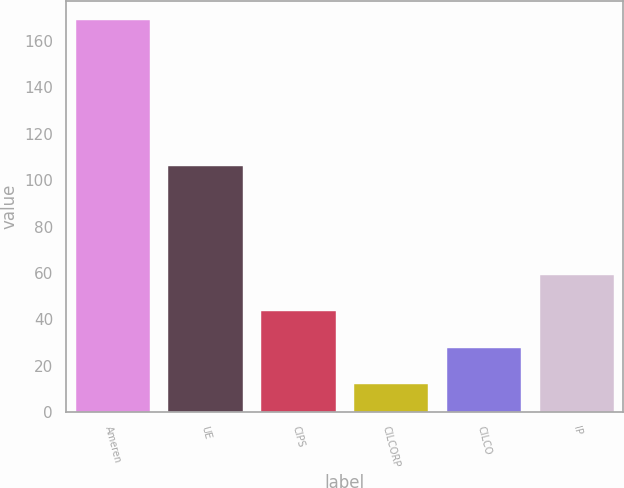Convert chart to OTSL. <chart><loc_0><loc_0><loc_500><loc_500><bar_chart><fcel>Ameren<fcel>UE<fcel>CIPS<fcel>CILCORP<fcel>CILCO<fcel>IP<nl><fcel>169<fcel>106<fcel>43.4<fcel>12<fcel>27.7<fcel>59.1<nl></chart> 